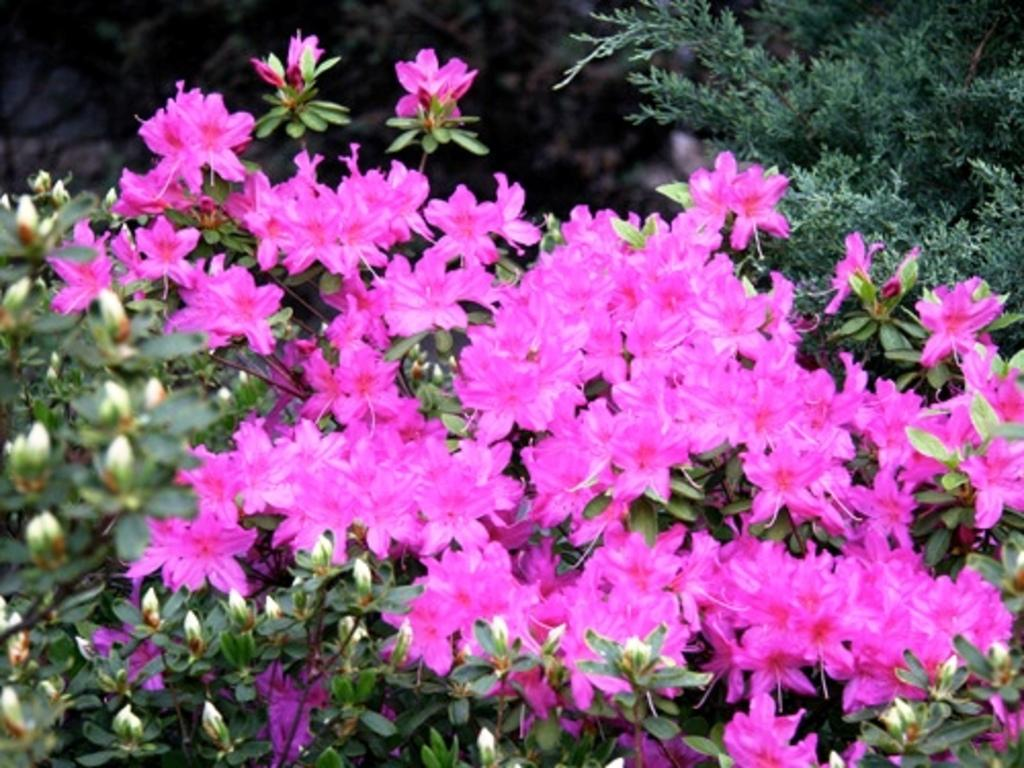What type of flowers can be seen in the image? There are pink flowers in the image. What stage of growth are some of the flowers in? There are buds in the image. What other plant parts can be seen in the image? There are leaves in the image. How would you describe the background of the image? The background of the image is blurred. What actor is performing in the image? There is no actor present in the image; it features flowers, buds, and leaves. What color is the boundary around the image? There is no boundary around the image, so it is not possible to determine its color. 